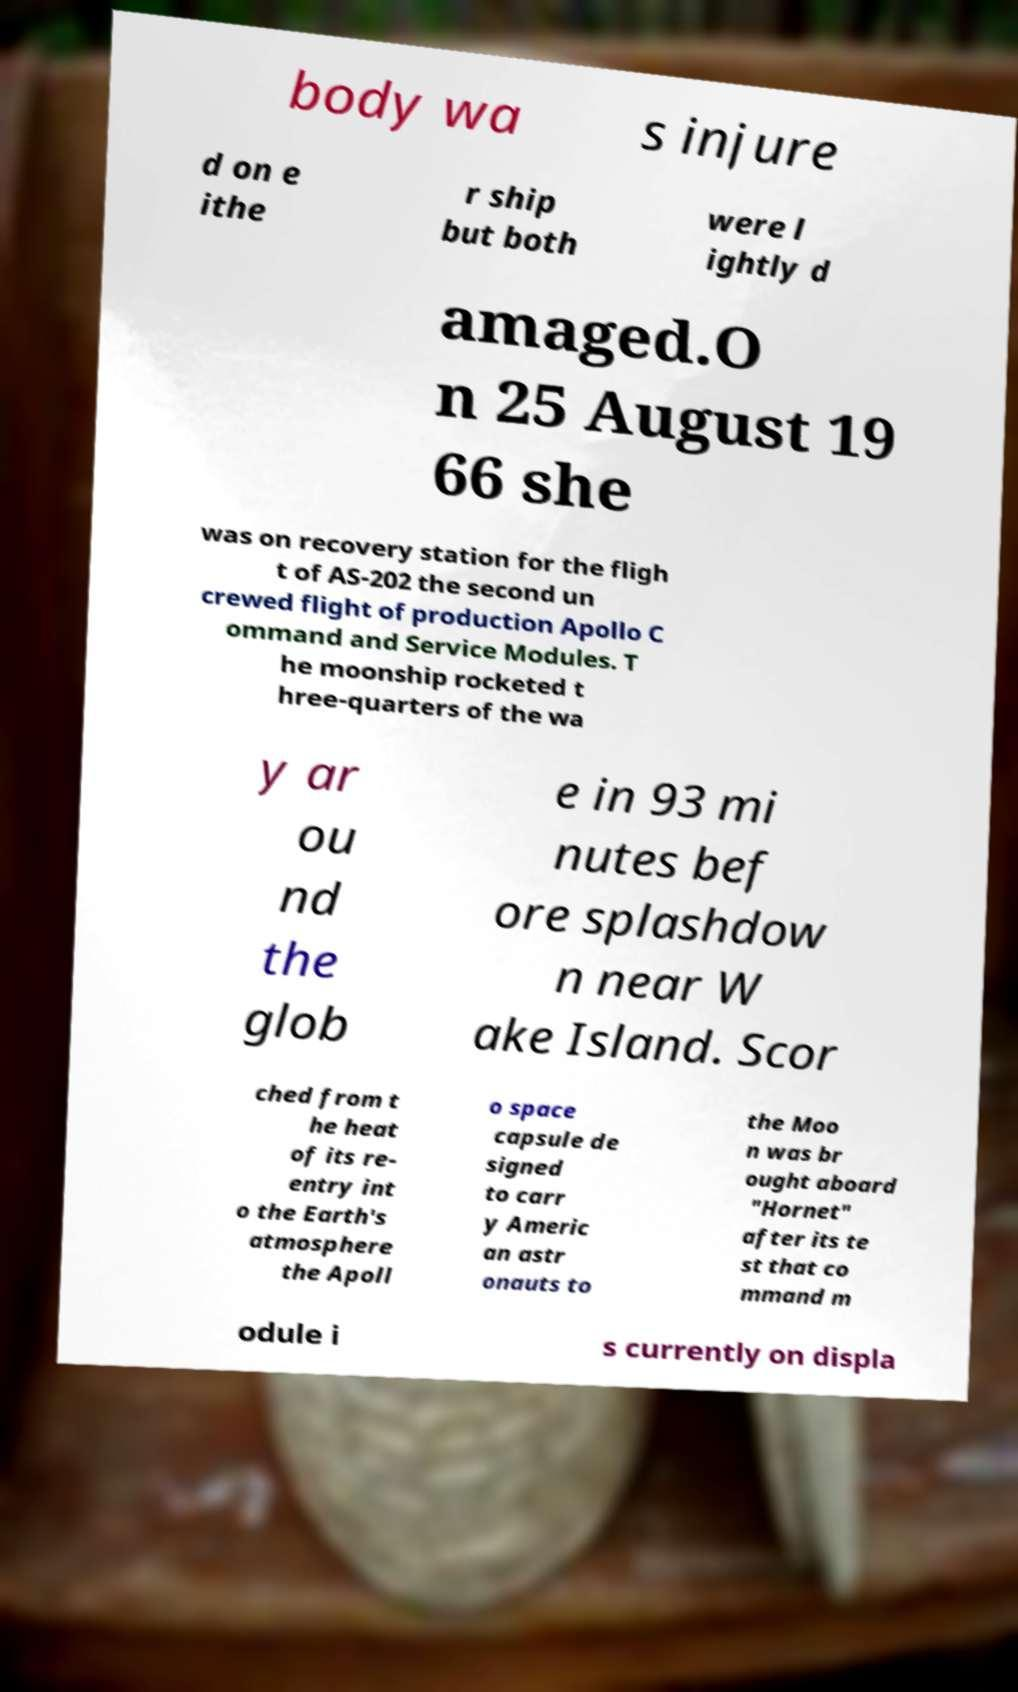There's text embedded in this image that I need extracted. Can you transcribe it verbatim? body wa s injure d on e ithe r ship but both were l ightly d amaged.O n 25 August 19 66 she was on recovery station for the fligh t of AS-202 the second un crewed flight of production Apollo C ommand and Service Modules. T he moonship rocketed t hree-quarters of the wa y ar ou nd the glob e in 93 mi nutes bef ore splashdow n near W ake Island. Scor ched from t he heat of its re- entry int o the Earth's atmosphere the Apoll o space capsule de signed to carr y Americ an astr onauts to the Moo n was br ought aboard "Hornet" after its te st that co mmand m odule i s currently on displa 